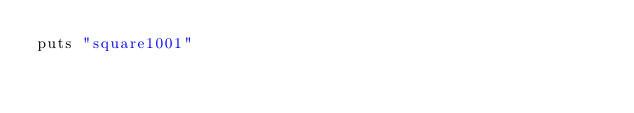<code> <loc_0><loc_0><loc_500><loc_500><_Ruby_>puts "square1001"
</code> 